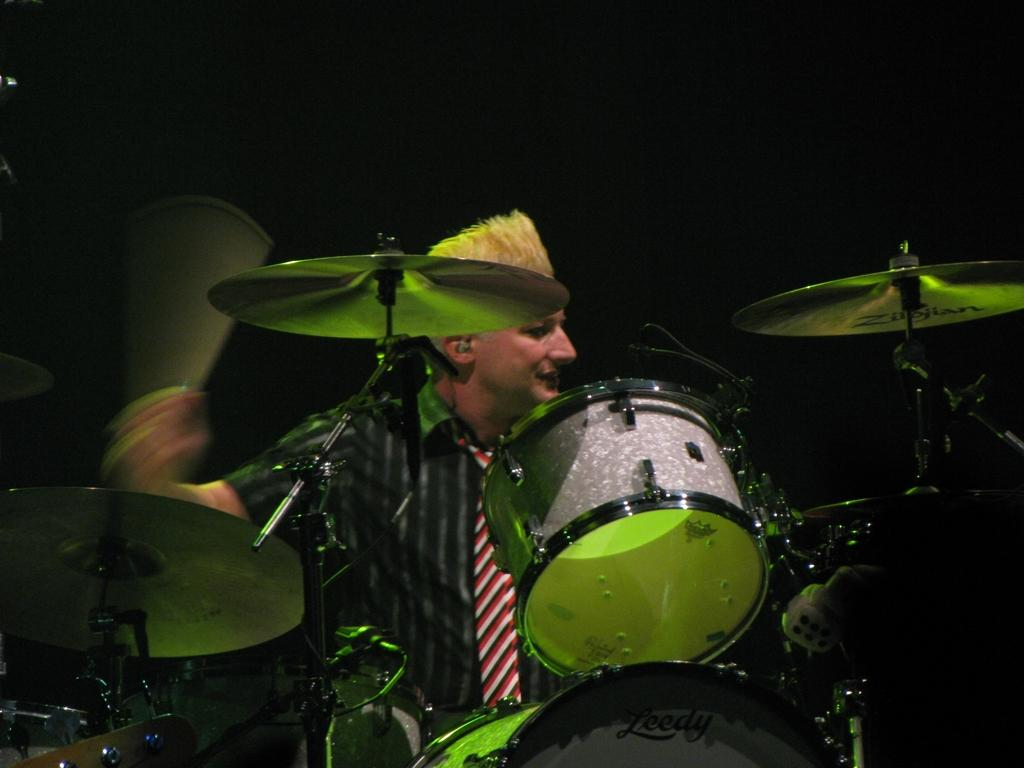Who is the main subject in the image? There is a man in the image. What is the man doing in the image? The man is playing a drum. What type of spark can be seen coming from the drum in the image? There is no spark visible in the image; the man is simply playing a drum. 